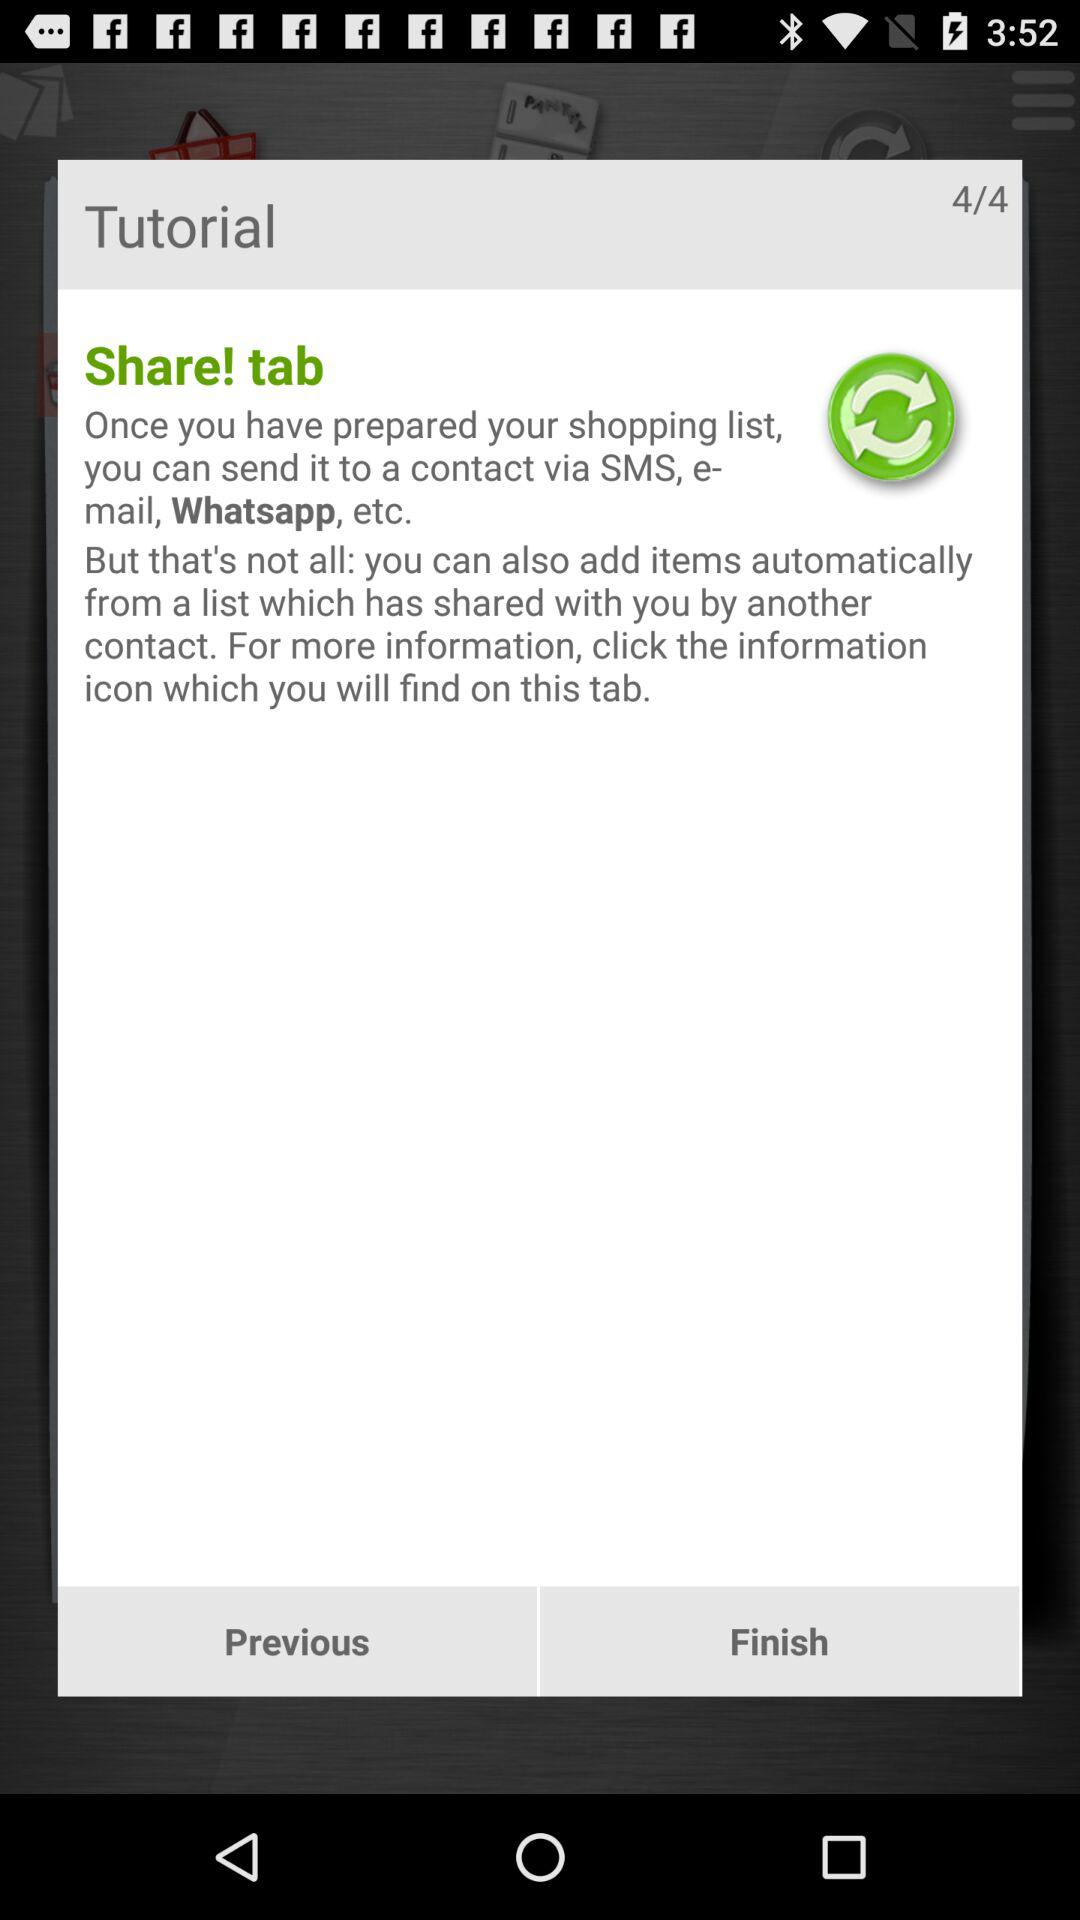What is the current page? The current page is 4. 